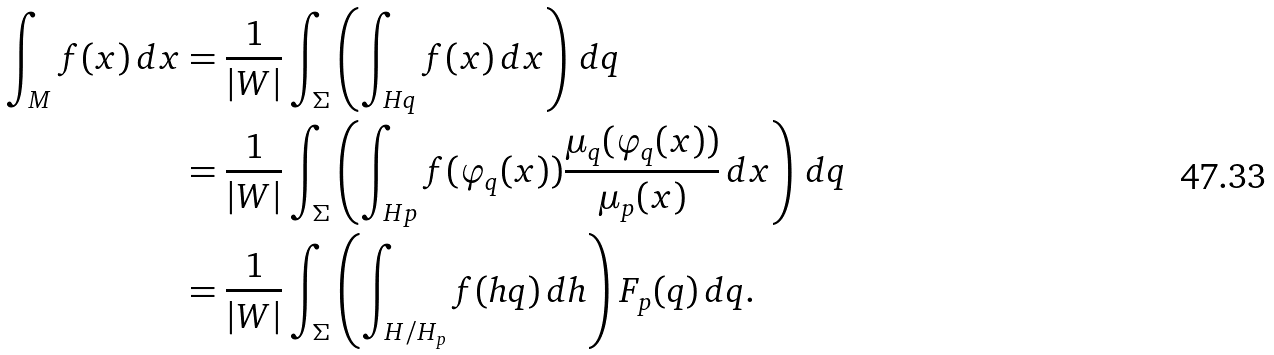<formula> <loc_0><loc_0><loc_500><loc_500>\int _ { M } f ( x ) \, d x & = \frac { 1 } { | W | } \int _ { \Sigma } \left ( \int _ { H q } f ( x ) \, d x \right ) \, d q \\ & = \frac { 1 } { | W | } \int _ { \Sigma } \left ( \int _ { H p } f ( \varphi _ { q } ( x ) ) \frac { \mu _ { q } ( \varphi _ { q } ( x ) ) } { \mu _ { p } ( x ) } \, d x \right ) \, d q \\ & = \frac { 1 } { | W | } \int _ { \Sigma } \left ( \int _ { H / H _ { p } } f ( h q ) \, d h \right ) F _ { p } ( q ) \, d q .</formula> 